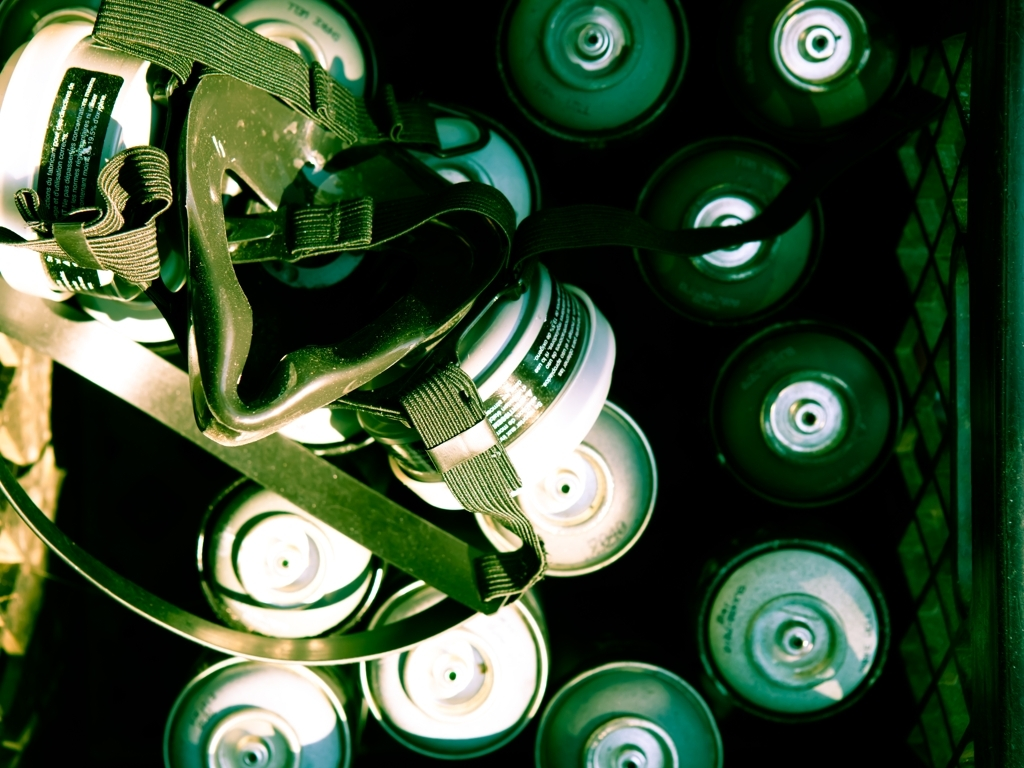Can you explain the potential use of the items in this image? It appears that the image displays spray paint cans and part of a respirator. These items are commonly used in spray painting, for artistic purposes such as graffiti or for tasks like painting vehicles and furniture. A respirator is important as it helps protect the user from inhaling harmful fumes. 